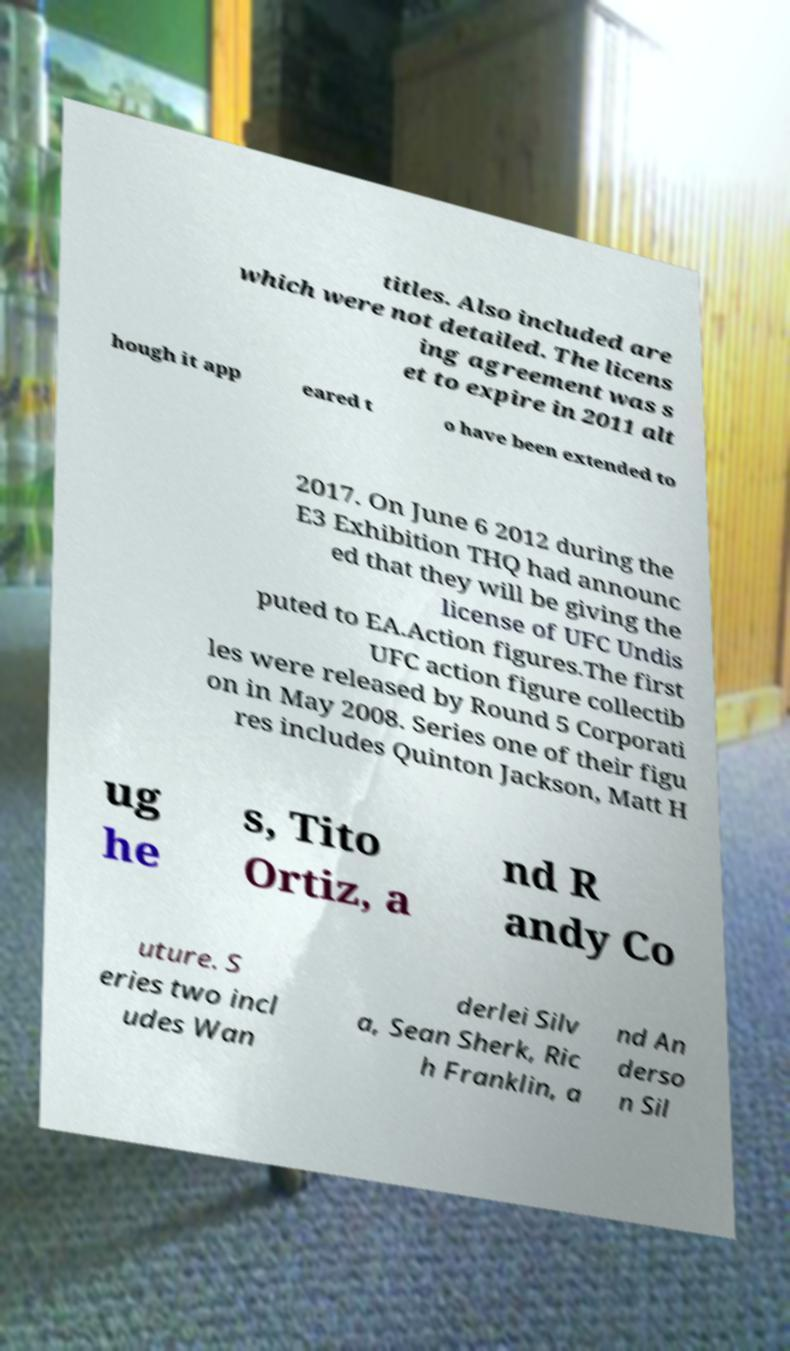Please read and relay the text visible in this image. What does it say? titles. Also included are which were not detailed. The licens ing agreement was s et to expire in 2011 alt hough it app eared t o have been extended to 2017. On June 6 2012 during the E3 Exhibition THQ had announc ed that they will be giving the license of UFC Undis puted to EA.Action figures.The first UFC action figure collectib les were released by Round 5 Corporati on in May 2008. Series one of their figu res includes Quinton Jackson, Matt H ug he s, Tito Ortiz, a nd R andy Co uture. S eries two incl udes Wan derlei Silv a, Sean Sherk, Ric h Franklin, a nd An derso n Sil 